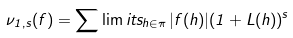Convert formula to latex. <formula><loc_0><loc_0><loc_500><loc_500>\nu _ { 1 , s } ( f ) = \sum \lim i t s _ { h \in \pi } \, | f ( h ) | ( 1 + L ( h ) ) ^ { s }</formula> 